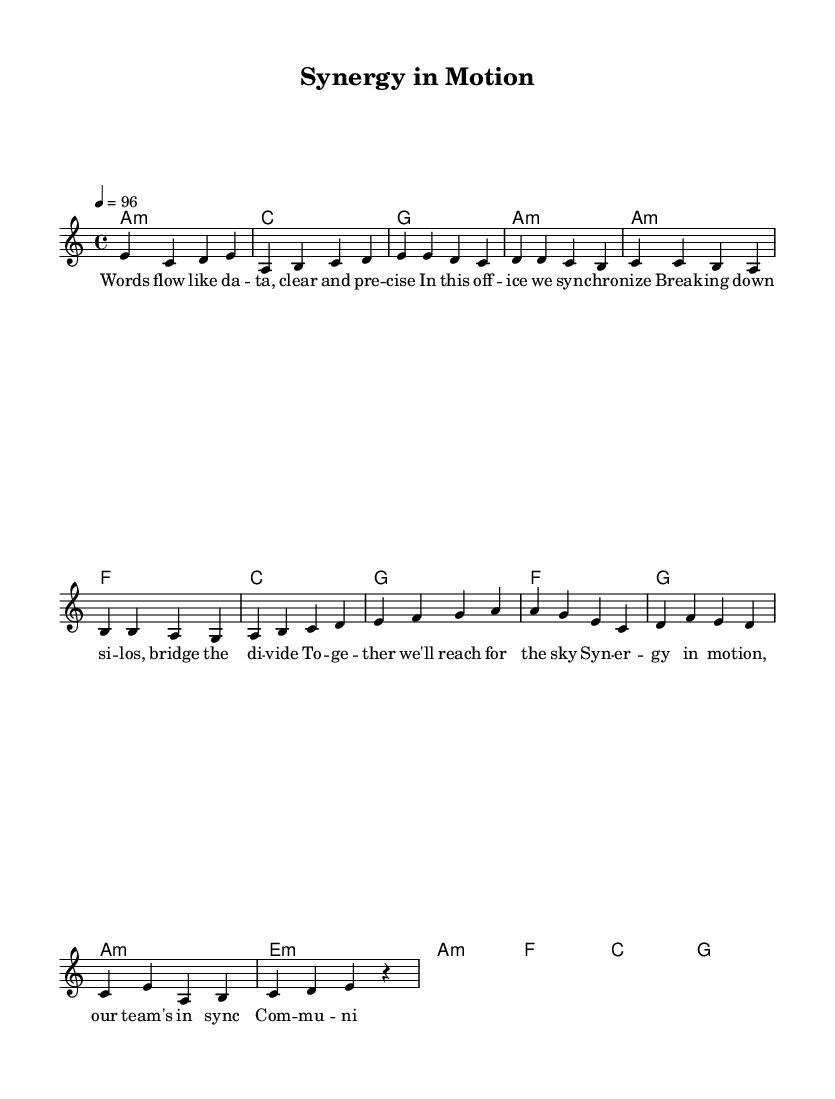What is the key signature of this music? The key signature can be determined from the global section where it states "\key a \minor". A minor has no sharps or flats.
Answer: A minor What is the time signature of this music? The time signature is indicated in the global section as "\time 4/4". This indicates that there are four beats in each measure, and the quarter note gets one beat.
Answer: 4/4 What is the tempo of this music? The tempo is stated in the global section as "\tempo 4 = 96", meaning there are 96 beats per minute. This sets the pace for how the music should be played.
Answer: 96 What is the theme expressed in the lyrics? The lyrics express concepts of teamwork and effective communication, as indicated by phrases like "In this office we synchronize" and "Together we'll reach for the sky." This reinforces cooperation in a professional setting.
Answer: Teamwork What harmony is played during the pre-chorus? The harmonies during the pre-chorus section are f, g, a minor, and e minor, as specified in the harmonic analysis section, which are played in a sequence during that part of the song.
Answer: f, g, a minor, e minor What musical form does this piece exemplify? The structure of the music follows a common song form, specifically: Intro, Verse, Pre-chorus, and Chorus. This aligns with typical K-Pop song frameworks that promote catchy melodies and repetitive structures.
Answer: Verse-Pre-Chorus-Chorus 